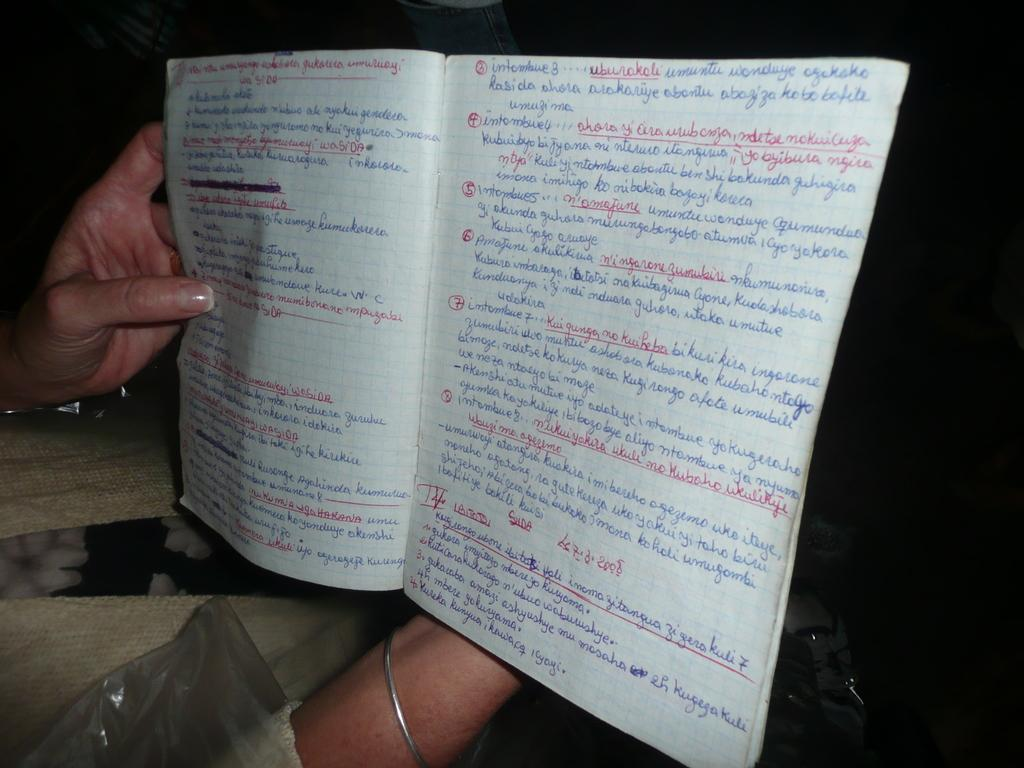What is being held by the hands in the image? The hands are holding a book. What can be found inside the book? The book contains written text. What part of the book is visible in the image? There is a cover visible at the bottom of the image. What type of company is being discussed in the book? There is no information about a company in the image or the book. Who is the writer of the book? The identity of the book's writer is not mentioned in the image or the provided facts. 